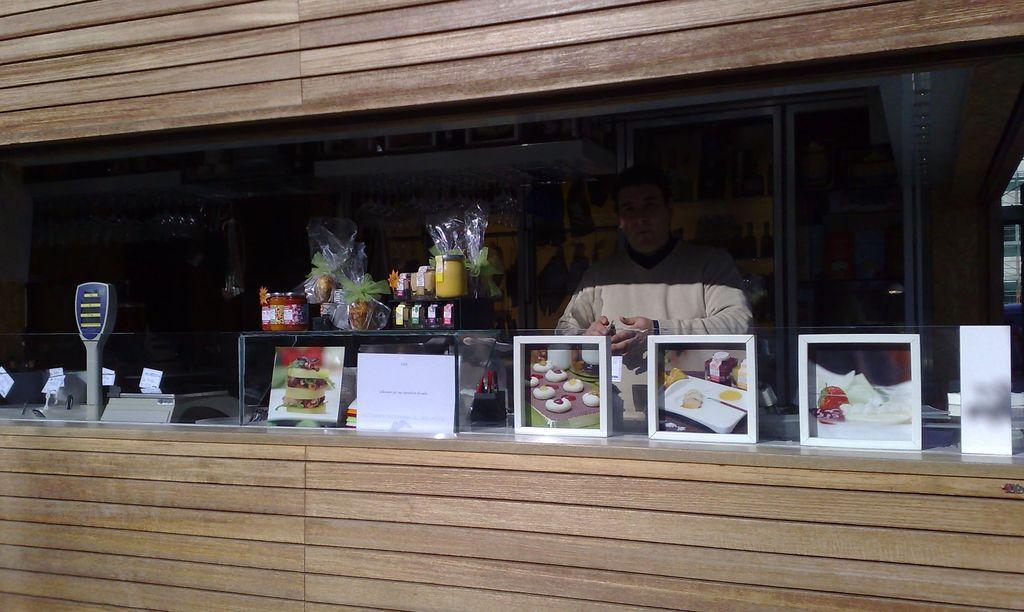How would you summarize this image in a sentence or two? This seems to be a stall. At the bottom and top sides of the image I can see the wooden walls. In the middle of the image there is a glass. Few photo frames are attached to this glass. Behind the glass there are some bottles and some other objects are placed and also I can see a man wearing a t-shirt. 